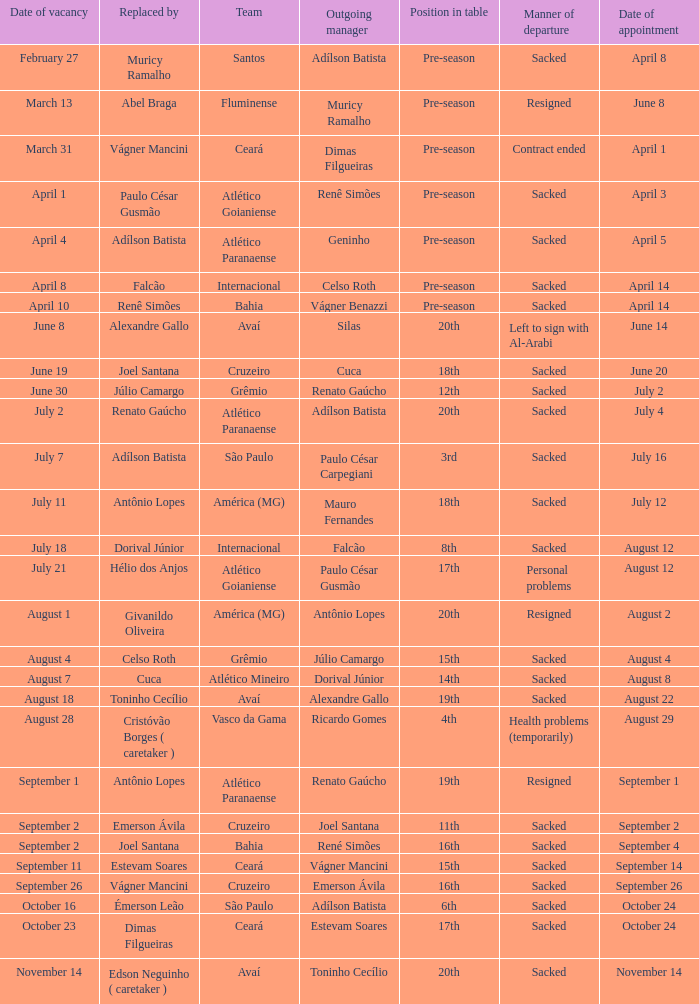How many times did Silas leave as a team manager? 1.0. Could you parse the entire table as a dict? {'header': ['Date of vacancy', 'Replaced by', 'Team', 'Outgoing manager', 'Position in table', 'Manner of departure', 'Date of appointment'], 'rows': [['February 27', 'Muricy Ramalho', 'Santos', 'Adílson Batista', 'Pre-season', 'Sacked', 'April 8'], ['March 13', 'Abel Braga', 'Fluminense', 'Muricy Ramalho', 'Pre-season', 'Resigned', 'June 8'], ['March 31', 'Vágner Mancini', 'Ceará', 'Dimas Filgueiras', 'Pre-season', 'Contract ended', 'April 1'], ['April 1', 'Paulo César Gusmão', 'Atlético Goianiense', 'Renê Simões', 'Pre-season', 'Sacked', 'April 3'], ['April 4', 'Adílson Batista', 'Atlético Paranaense', 'Geninho', 'Pre-season', 'Sacked', 'April 5'], ['April 8', 'Falcão', 'Internacional', 'Celso Roth', 'Pre-season', 'Sacked', 'April 14'], ['April 10', 'Renê Simões', 'Bahia', 'Vágner Benazzi', 'Pre-season', 'Sacked', 'April 14'], ['June 8', 'Alexandre Gallo', 'Avaí', 'Silas', '20th', 'Left to sign with Al-Arabi', 'June 14'], ['June 19', 'Joel Santana', 'Cruzeiro', 'Cuca', '18th', 'Sacked', 'June 20'], ['June 30', 'Júlio Camargo', 'Grêmio', 'Renato Gaúcho', '12th', 'Sacked', 'July 2'], ['July 2', 'Renato Gaúcho', 'Atlético Paranaense', 'Adílson Batista', '20th', 'Sacked', 'July 4'], ['July 7', 'Adílson Batista', 'São Paulo', 'Paulo César Carpegiani', '3rd', 'Sacked', 'July 16'], ['July 11', 'Antônio Lopes', 'América (MG)', 'Mauro Fernandes', '18th', 'Sacked', 'July 12'], ['July 18', 'Dorival Júnior', 'Internacional', 'Falcão', '8th', 'Sacked', 'August 12'], ['July 21', 'Hélio dos Anjos', 'Atlético Goianiense', 'Paulo César Gusmão', '17th', 'Personal problems', 'August 12'], ['August 1', 'Givanildo Oliveira', 'América (MG)', 'Antônio Lopes', '20th', 'Resigned', 'August 2'], ['August 4', 'Celso Roth', 'Grêmio', 'Júlio Camargo', '15th', 'Sacked', 'August 4'], ['August 7', 'Cuca', 'Atlético Mineiro', 'Dorival Júnior', '14th', 'Sacked', 'August 8'], ['August 18', 'Toninho Cecílio', 'Avaí', 'Alexandre Gallo', '19th', 'Sacked', 'August 22'], ['August 28', 'Cristóvão Borges ( caretaker )', 'Vasco da Gama', 'Ricardo Gomes', '4th', 'Health problems (temporarily)', 'August 29'], ['September 1', 'Antônio Lopes', 'Atlético Paranaense', 'Renato Gaúcho', '19th', 'Resigned', 'September 1'], ['September 2', 'Emerson Ávila', 'Cruzeiro', 'Joel Santana', '11th', 'Sacked', 'September 2'], ['September 2', 'Joel Santana', 'Bahia', 'René Simões', '16th', 'Sacked', 'September 4'], ['September 11', 'Estevam Soares', 'Ceará', 'Vágner Mancini', '15th', 'Sacked', 'September 14'], ['September 26', 'Vágner Mancini', 'Cruzeiro', 'Emerson Ávila', '16th', 'Sacked', 'September 26'], ['October 16', 'Émerson Leão', 'São Paulo', 'Adílson Batista', '6th', 'Sacked', 'October 24'], ['October 23', 'Dimas Filgueiras', 'Ceará', 'Estevam Soares', '17th', 'Sacked', 'October 24'], ['November 14', 'Edson Neguinho ( caretaker )', 'Avaí', 'Toninho Cecílio', '20th', 'Sacked', 'November 14']]} 